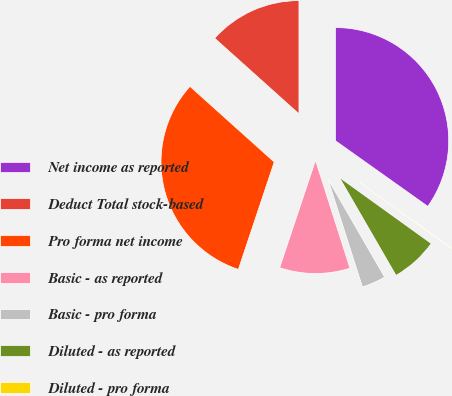<chart> <loc_0><loc_0><loc_500><loc_500><pie_chart><fcel>Net income as reported<fcel>Deduct Total stock-based<fcel>Pro forma net income<fcel>Basic - as reported<fcel>Basic - pro forma<fcel>Diluted - as reported<fcel>Diluted - pro forma<nl><fcel>34.83%<fcel>13.36%<fcel>31.51%<fcel>10.05%<fcel>3.42%<fcel>6.73%<fcel>0.1%<nl></chart> 